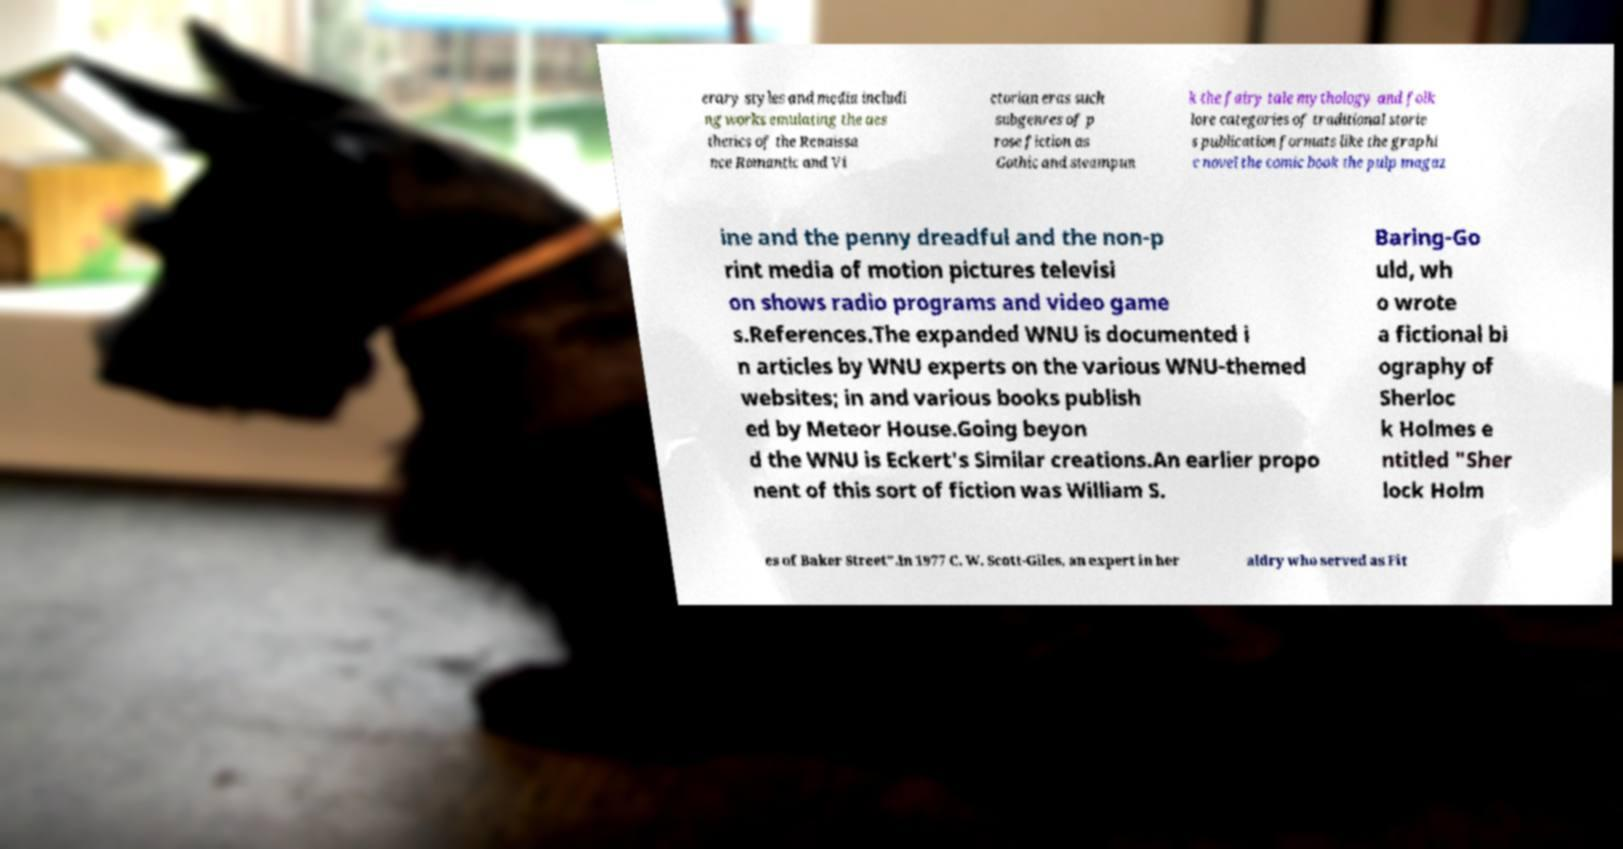What messages or text are displayed in this image? I need them in a readable, typed format. erary styles and media includi ng works emulating the aes thetics of the Renaissa nce Romantic and Vi ctorian eras such subgenres of p rose fiction as Gothic and steampun k the fairy tale mythology and folk lore categories of traditional storie s publication formats like the graphi c novel the comic book the pulp magaz ine and the penny dreadful and the non-p rint media of motion pictures televisi on shows radio programs and video game s.References.The expanded WNU is documented i n articles by WNU experts on the various WNU-themed websites; in and various books publish ed by Meteor House.Going beyon d the WNU is Eckert's Similar creations.An earlier propo nent of this sort of fiction was William S. Baring-Go uld, wh o wrote a fictional bi ography of Sherloc k Holmes e ntitled "Sher lock Holm es of Baker Street".In 1977 C. W. Scott-Giles, an expert in her aldry who served as Fit 